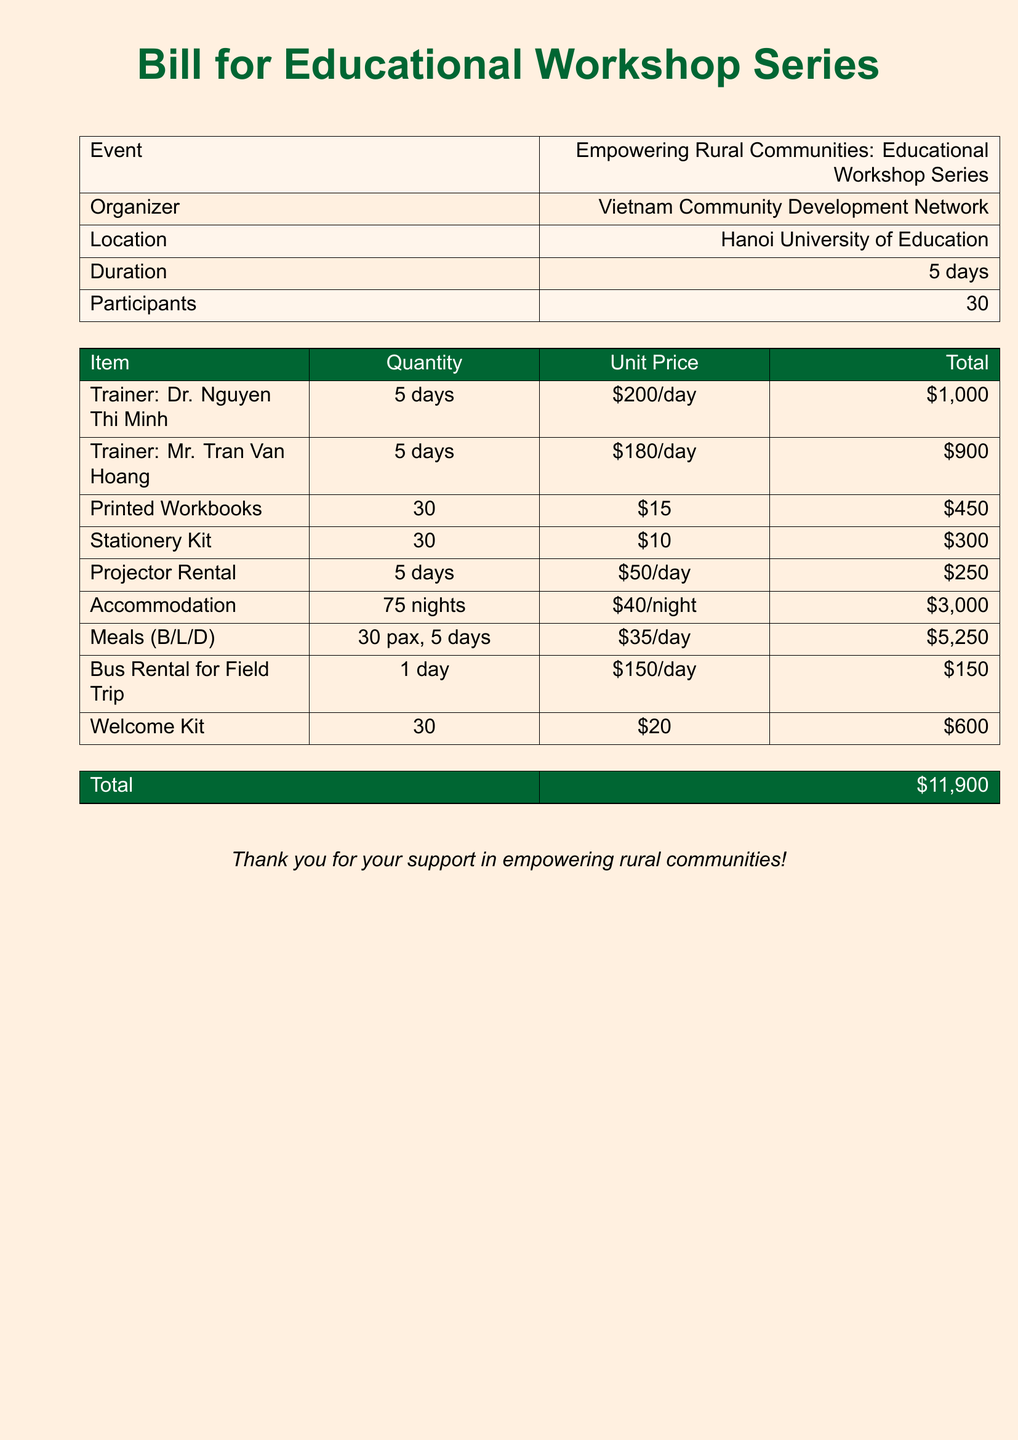what is the total cost? The total cost is stated at the bottom of the bill, which sums up all individual expenses listed.
Answer: $11,900 who is the trainer with the highest daily rate? The trainers and their respective daily rates are provided in the document, revealing the highest rate.
Answer: Dr. Nguyen Thi Minh how many participants are there in the workshop? The number of participants is specifically mentioned in the overview of the event.
Answer: 30 what is the total accommodation cost? The accommodation cost is calculated based on the quantity of nights and the unit price per night.
Answer: $3,000 how many printed workbooks are provided? The document lists the quantity of printed workbooks allocated for the participants.
Answer: 30 what is the unit price for the projector rental? The unit price for the projector rental is stated in the cost breakdown section of the bill.
Answer: $50/day who organized the workshop series? The organizer's name is mentioned in the header section of the document.
Answer: Vietnam Community Development Network how long does the workshop last? The duration of the workshop is clearly stated in the event details.
Answer: 5 days what is included in the meals cost? The meals cost is specified based on the number of meals provided per day for participants.
Answer: B/L/D 